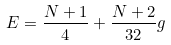Convert formula to latex. <formula><loc_0><loc_0><loc_500><loc_500>E = \frac { N + 1 } { 4 } + \frac { N + 2 } { 3 2 } g</formula> 